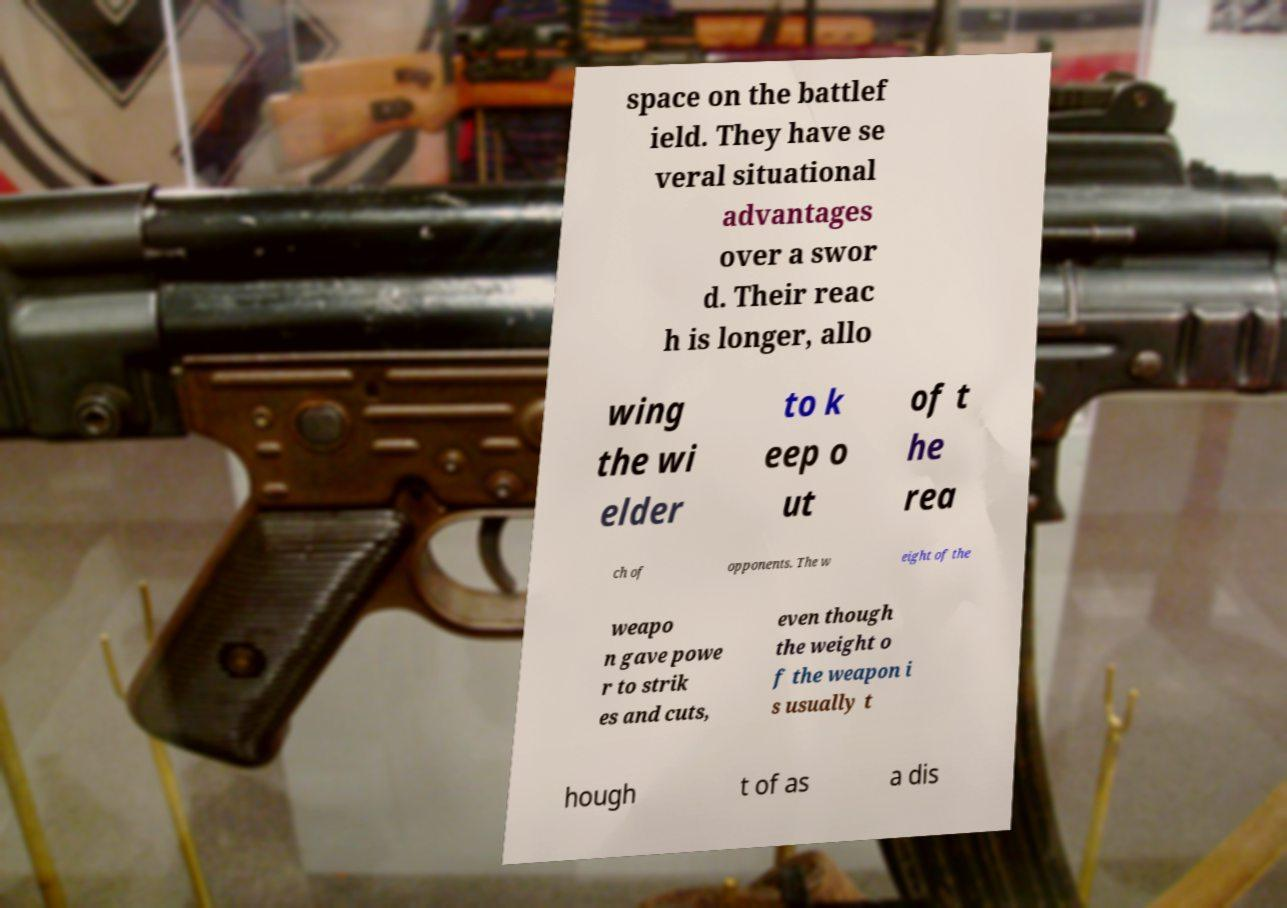I need the written content from this picture converted into text. Can you do that? space on the battlef ield. They have se veral situational advantages over a swor d. Their reac h is longer, allo wing the wi elder to k eep o ut of t he rea ch of opponents. The w eight of the weapo n gave powe r to strik es and cuts, even though the weight o f the weapon i s usually t hough t of as a dis 